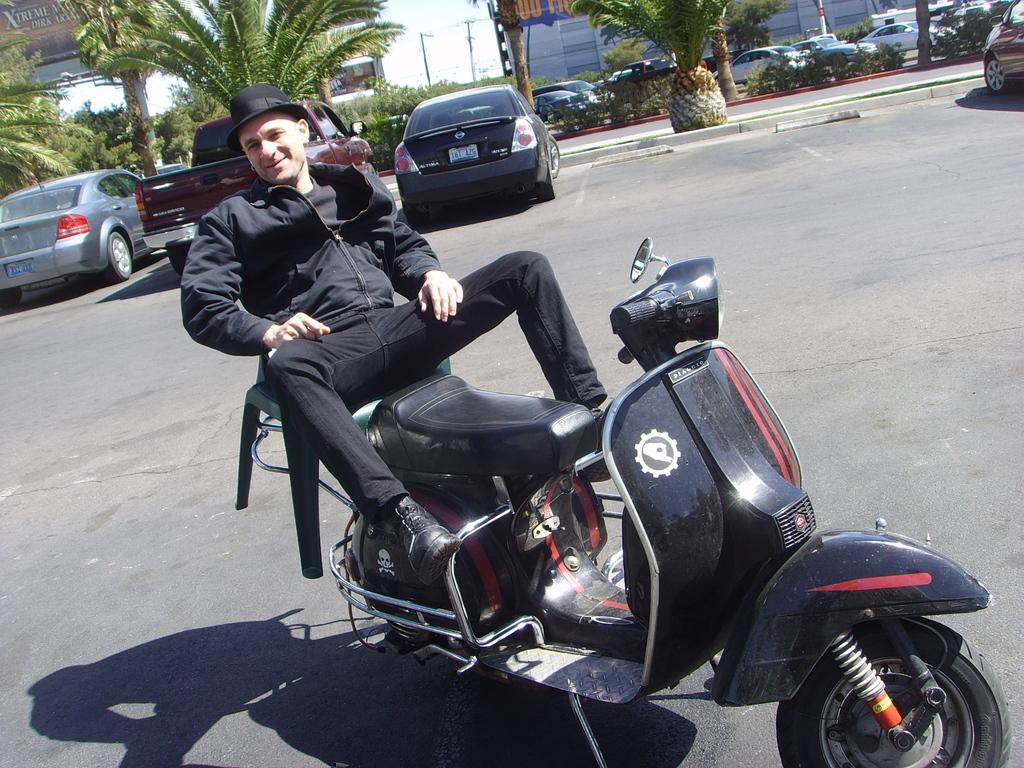How would you summarize this image in a sentence or two? In this image, there are a few vehicles. We can see the ground. There are few trees, poles and partially covered buildings. We can also see some plants and boards with text. We can see the sky. We can also see a person on one of the vehicles. 